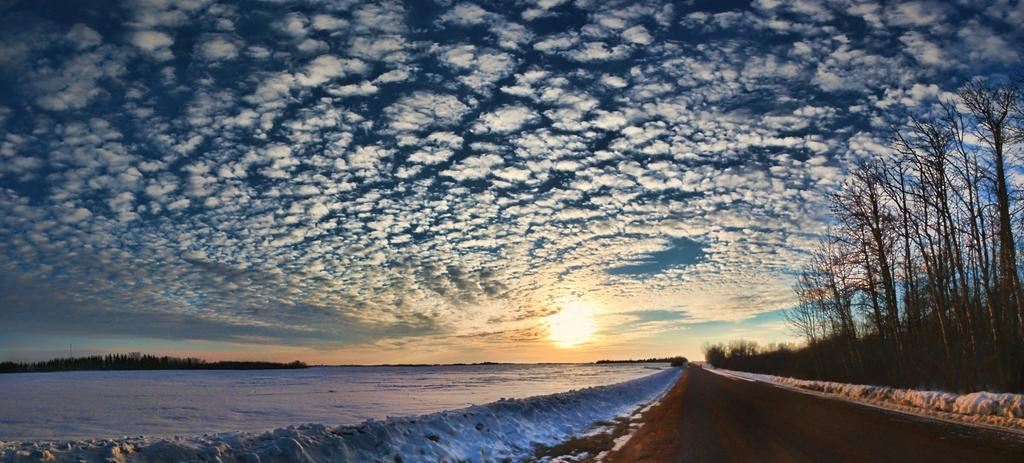What type of surface can be seen in the image? There is a road in the image. What weather condition is depicted in the image? There is snow visible in the image. What type of vegetation is present in the image? There are trees in the image. What can be seen in the background of the image? The sky is visible in the background of the image. What is the condition of the sky in the image? Clouds are present in the sky. What type of pancake is being served on the road in the image? There is no pancake present in the image; it features a road with snow and trees. How many units are visible in the image? There is no reference to any units in the image, so it's not possible to determine the number of units. 